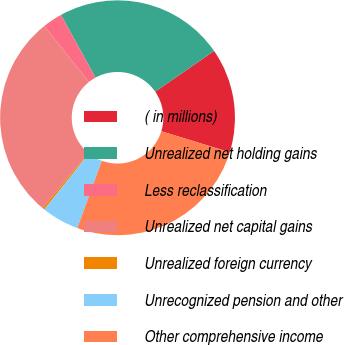Convert chart to OTSL. <chart><loc_0><loc_0><loc_500><loc_500><pie_chart><fcel>( in millions)<fcel>Unrealized net holding gains<fcel>Less reclassification<fcel>Unrealized net capital gains<fcel>Unrealized foreign currency<fcel>Unrecognized pension and other<fcel>Other comprehensive income<nl><fcel>14.39%<fcel>23.36%<fcel>2.73%<fcel>28.24%<fcel>0.29%<fcel>5.17%<fcel>25.8%<nl></chart> 